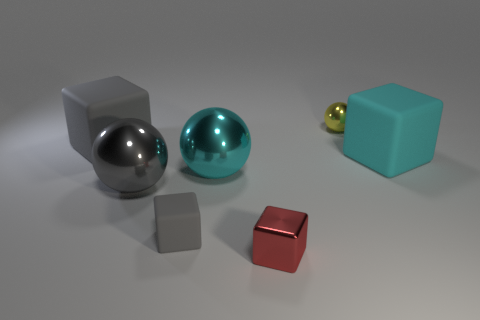How is the lighting affecting the appearance of the objects? The lighting in the image is creating distinct highlights and shadows on the objects, enhancing their three-dimensional appearance. The reflective spheres show clear specular highlights, while the cubes, with their flatter surfaces, display softer highlights and more defined shadows. 